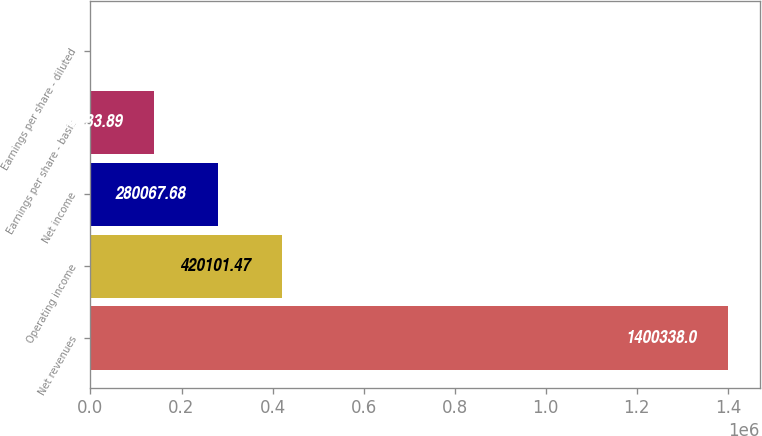Convert chart to OTSL. <chart><loc_0><loc_0><loc_500><loc_500><bar_chart><fcel>Net revenues<fcel>Operating income<fcel>Net income<fcel>Earnings per share - basic<fcel>Earnings per share - diluted<nl><fcel>1.40034e+06<fcel>420101<fcel>280068<fcel>140034<fcel>0.1<nl></chart> 